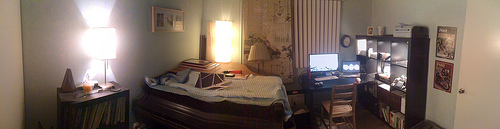Please provide a short description for this region: [0.91, 0.53, 0.93, 0.57]. The specified coordinates refer to a silver, rounded knob situated on the lower half of a white-paneled door within a warmly lit room. 